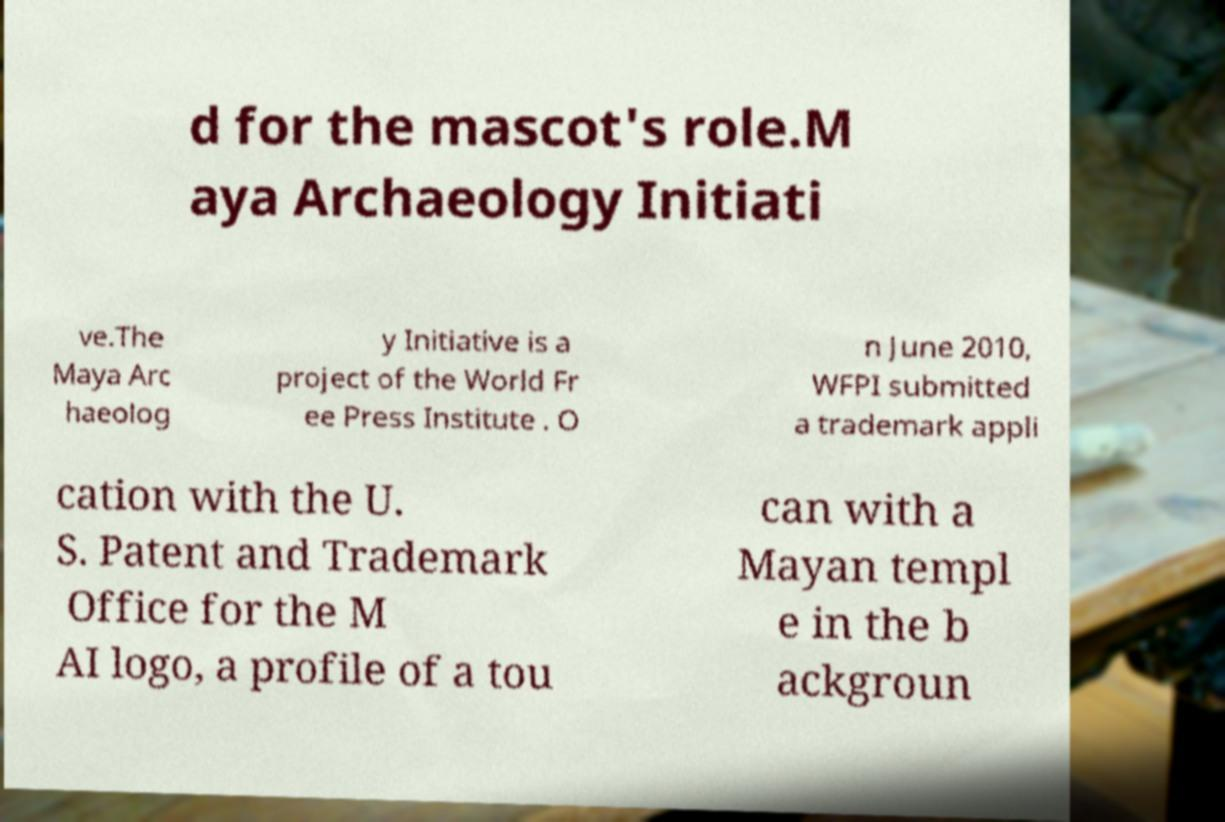What messages or text are displayed in this image? I need them in a readable, typed format. d for the mascot's role.M aya Archaeology Initiati ve.The Maya Arc haeolog y Initiative is a project of the World Fr ee Press Institute . O n June 2010, WFPI submitted a trademark appli cation with the U. S. Patent and Trademark Office for the M AI logo, a profile of a tou can with a Mayan templ e in the b ackgroun 